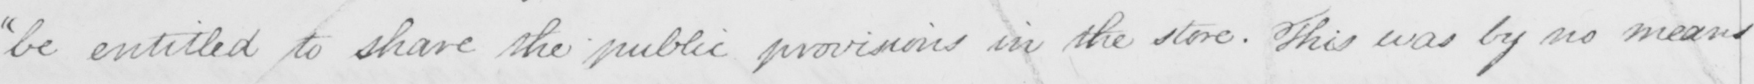Please provide the text content of this handwritten line. " be entitled to share the public provisions in the store . This was by no means 